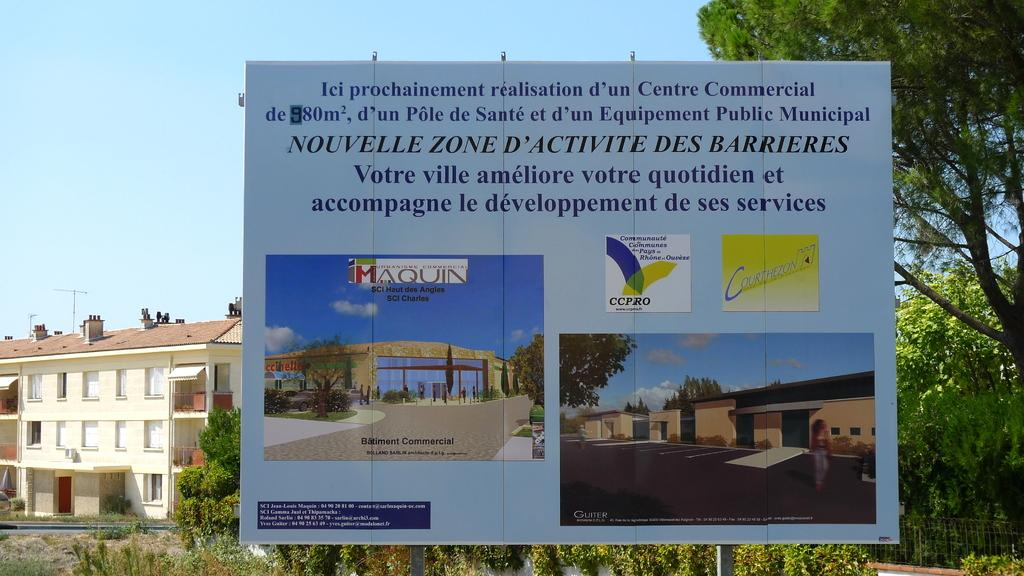What is present on the poster in the image? The poster contains a picture and logos. Is there any text on the poster? Yes, there is text on the poster. What can be seen in the background behind the poster? Trees and houses are visible behind the poster. What type of gold kettle can be seen on the holiday in the image? There is no gold kettle or holiday present in the image; it features a poster with a picture, logos, and text, along with trees and houses in the background. 